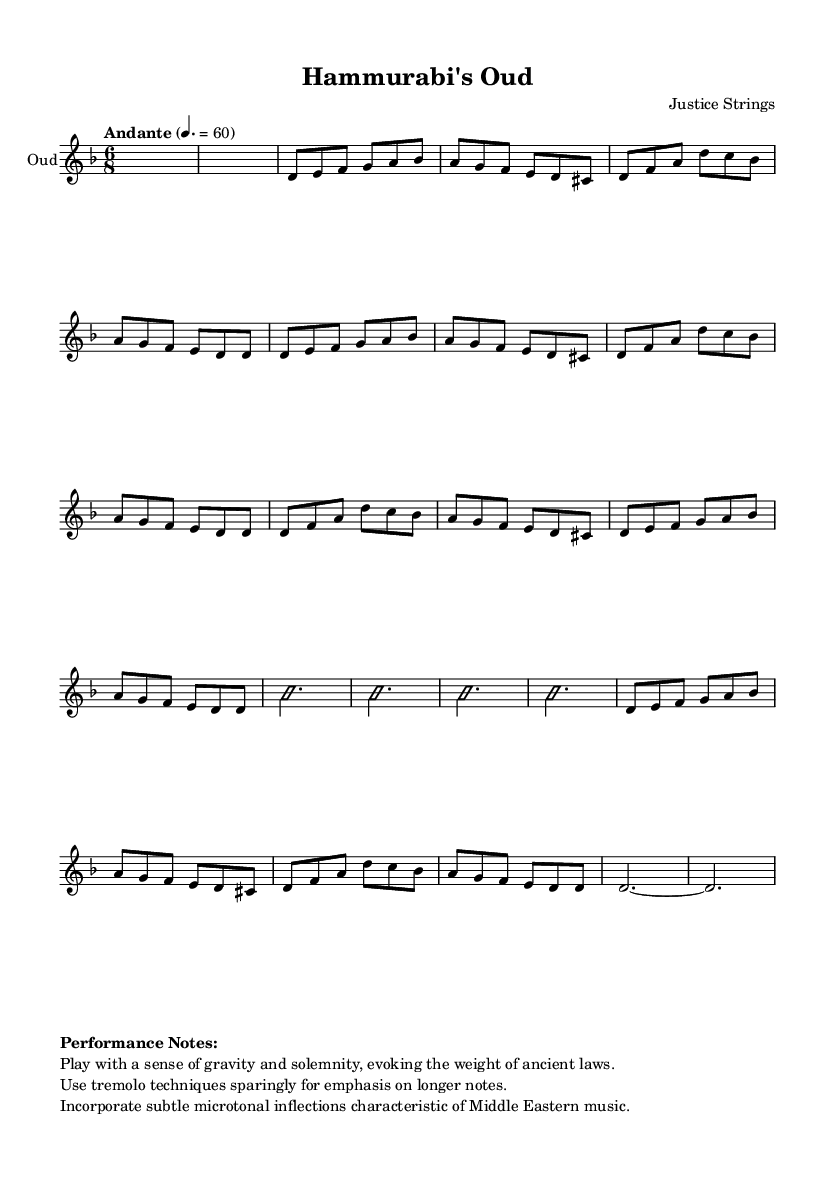What is the key signature of this music? The key signature is identified by the presence of the "bes" note in the scale, indicating it includes B flat, thereby indicating the key of D minor.
Answer: D minor What is the time signature of this music? The time signature appears at the beginning of the score, showing a 6/8 format which indicates six eighth notes per measure, creating a compound meter.
Answer: 6/8 What is the tempo marking indicated in this piece? The tempo marking, stated in the music, is "Andante," which describes a moderate walking pace. The metronome setting is given as "4. = 60."
Answer: Andante How many main themes are present in the score? By analyzing the structure of the piece, it includes two distinct main themes labeled A and B followed by a variation.
Answer: Two What technique is suggested for emphasizing longer notes? The performance notes mention the use of tremolo techniques sparingly to bring out the weight of specific notes, especially longer ones.
Answer: Tremolo What does the improvisation section signify in the composition? The section labeled "\improvisationOn" indicates an area where the performer is encouraged to improvise, reflecting the flexibility and expression present in Middle Eastern music traditions.
Answer: Improvisation How should the performer convey the gravity of the piece? The performance notes specifically state to "play with a sense of gravity and solemnity," suggesting that the emotional delivery should reflect the weight of the ancient laws it draws inspiration from.
Answer: Gravity 